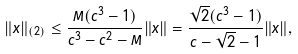<formula> <loc_0><loc_0><loc_500><loc_500>\| x \| _ { ( 2 ) } \leq \frac { M ( c ^ { 3 } - 1 ) } { c ^ { 3 } - c ^ { 2 } - M } \| x \| = \frac { \sqrt { 2 } ( c ^ { 3 } - 1 ) } { c - \sqrt { 2 } - 1 } \| x \| ,</formula> 